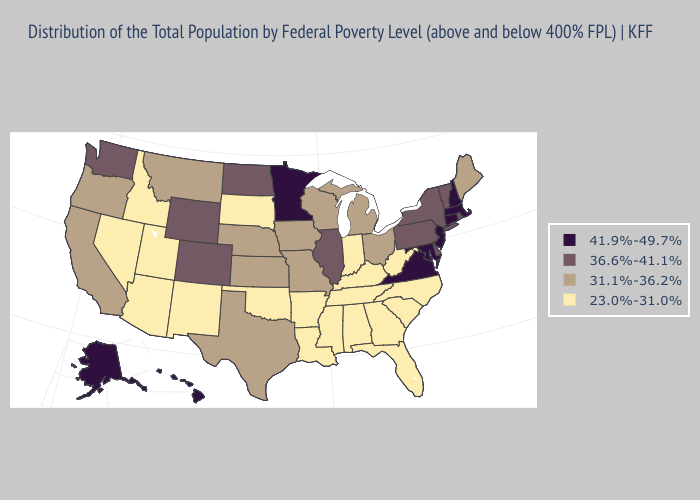Does Illinois have the highest value in the MidWest?
Quick response, please. No. What is the value of Wisconsin?
Concise answer only. 31.1%-36.2%. Does Maine have the lowest value in the Northeast?
Answer briefly. Yes. Name the states that have a value in the range 36.6%-41.1%?
Concise answer only. Colorado, Delaware, Illinois, New York, North Dakota, Pennsylvania, Rhode Island, Vermont, Washington, Wyoming. What is the lowest value in the USA?
Be succinct. 23.0%-31.0%. Is the legend a continuous bar?
Keep it brief. No. Does Nevada have a higher value than Iowa?
Keep it brief. No. What is the lowest value in the USA?
Give a very brief answer. 23.0%-31.0%. Does the map have missing data?
Answer briefly. No. Is the legend a continuous bar?
Quick response, please. No. Does Arizona have the highest value in the West?
Concise answer only. No. What is the lowest value in the USA?
Quick response, please. 23.0%-31.0%. What is the value of Kentucky?
Write a very short answer. 23.0%-31.0%. Among the states that border California , does Oregon have the lowest value?
Write a very short answer. No. What is the value of Minnesota?
Concise answer only. 41.9%-49.7%. 